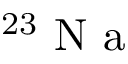<formula> <loc_0><loc_0><loc_500><loc_500>^ { 2 3 } N a</formula> 